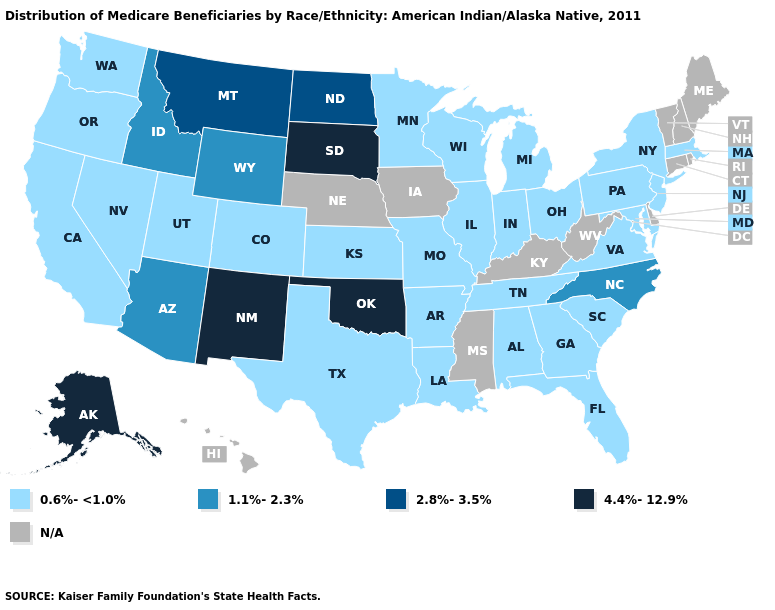Which states hav the highest value in the MidWest?
Answer briefly. South Dakota. What is the value of Maine?
Write a very short answer. N/A. What is the lowest value in the Northeast?
Concise answer only. 0.6%-<1.0%. Which states have the lowest value in the West?
Write a very short answer. California, Colorado, Nevada, Oregon, Utah, Washington. Among the states that border Idaho , does Montana have the highest value?
Quick response, please. Yes. What is the value of Oregon?
Short answer required. 0.6%-<1.0%. Which states hav the highest value in the Northeast?
Answer briefly. Massachusetts, New Jersey, New York, Pennsylvania. What is the value of Michigan?
Keep it brief. 0.6%-<1.0%. What is the value of Louisiana?
Short answer required. 0.6%-<1.0%. Does the first symbol in the legend represent the smallest category?
Answer briefly. Yes. Name the states that have a value in the range 0.6%-<1.0%?
Write a very short answer. Alabama, Arkansas, California, Colorado, Florida, Georgia, Illinois, Indiana, Kansas, Louisiana, Maryland, Massachusetts, Michigan, Minnesota, Missouri, Nevada, New Jersey, New York, Ohio, Oregon, Pennsylvania, South Carolina, Tennessee, Texas, Utah, Virginia, Washington, Wisconsin. Does Missouri have the lowest value in the USA?
Write a very short answer. Yes. What is the value of Virginia?
Answer briefly. 0.6%-<1.0%. Among the states that border Nebraska , does Kansas have the lowest value?
Short answer required. Yes. 